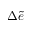<formula> <loc_0><loc_0><loc_500><loc_500>\Delta \widetilde { e }</formula> 